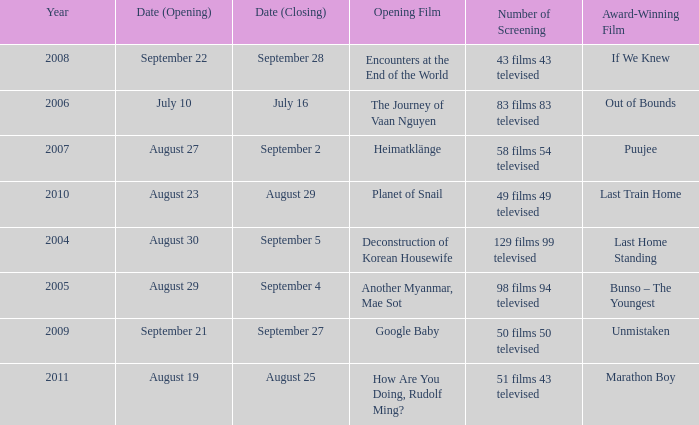Which opening film has the opening date of august 23? Planet of Snail. 